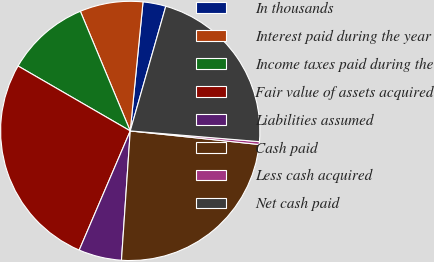Convert chart to OTSL. <chart><loc_0><loc_0><loc_500><loc_500><pie_chart><fcel>In thousands<fcel>Interest paid during the year<fcel>Income taxes paid during the<fcel>Fair value of assets acquired<fcel>Liabilities assumed<fcel>Cash paid<fcel>Less cash acquired<fcel>Net cash paid<nl><fcel>2.85%<fcel>7.86%<fcel>10.36%<fcel>26.91%<fcel>5.36%<fcel>24.41%<fcel>0.35%<fcel>21.9%<nl></chart> 